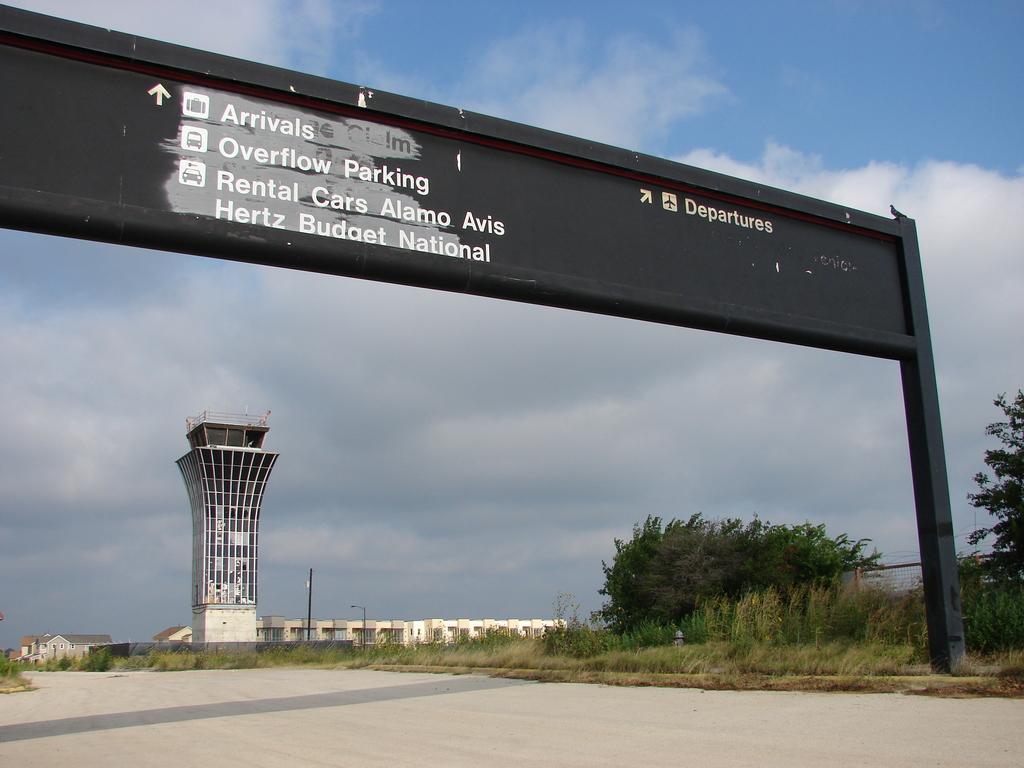What area is to the right?
Make the answer very short. Departures. Is rental cars straight ahead?
Your answer should be very brief. Yes. 